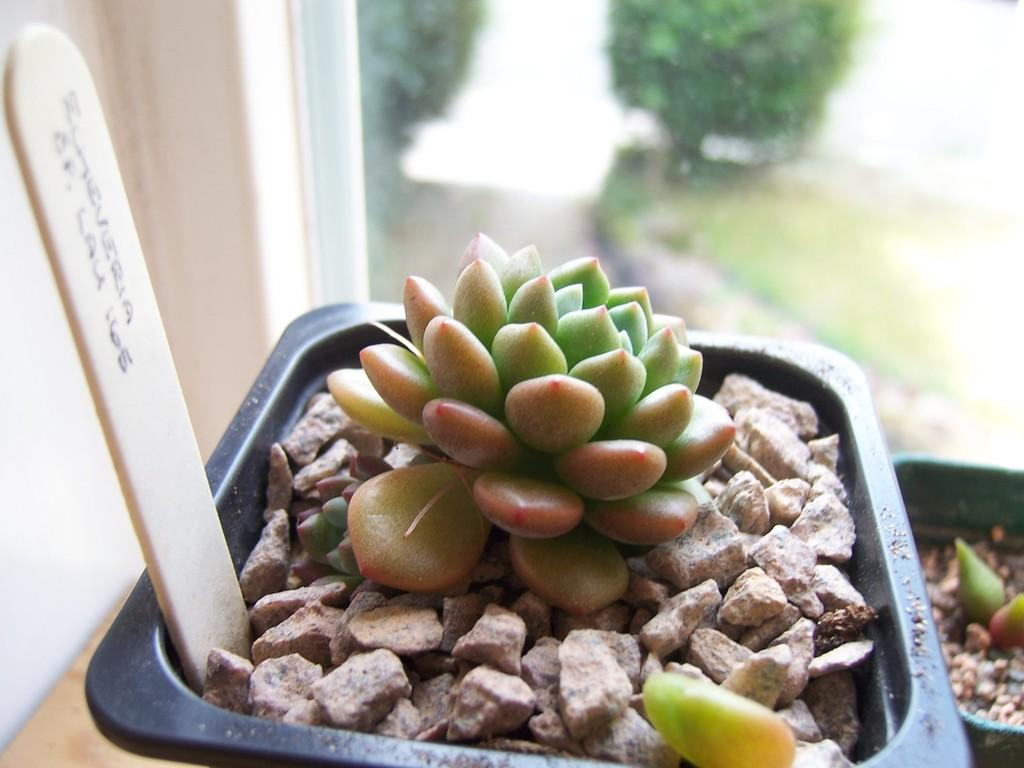What is located in the foreground of the image? There are houseplants, stones, and a stick in the foreground of the image. What can be seen in the background of the image? There is a window, trees, and a wall in the background of the image. What type of setting is suggested by the presence of a window and wall? The image is likely taken in a room, as indicated by the presence of a window and wall. What type of tree is growing out of the head of the person in the image? There is no person or tree growing out of a head in the image; it features houseplants, stones, and a stick in the foreground, and a window, trees, and a wall in the background. What is the reason for the war depicted in the image? There is no war depicted in the image; it shows a room with houseplants, stones, a stick, a window, trees, and a wall. 